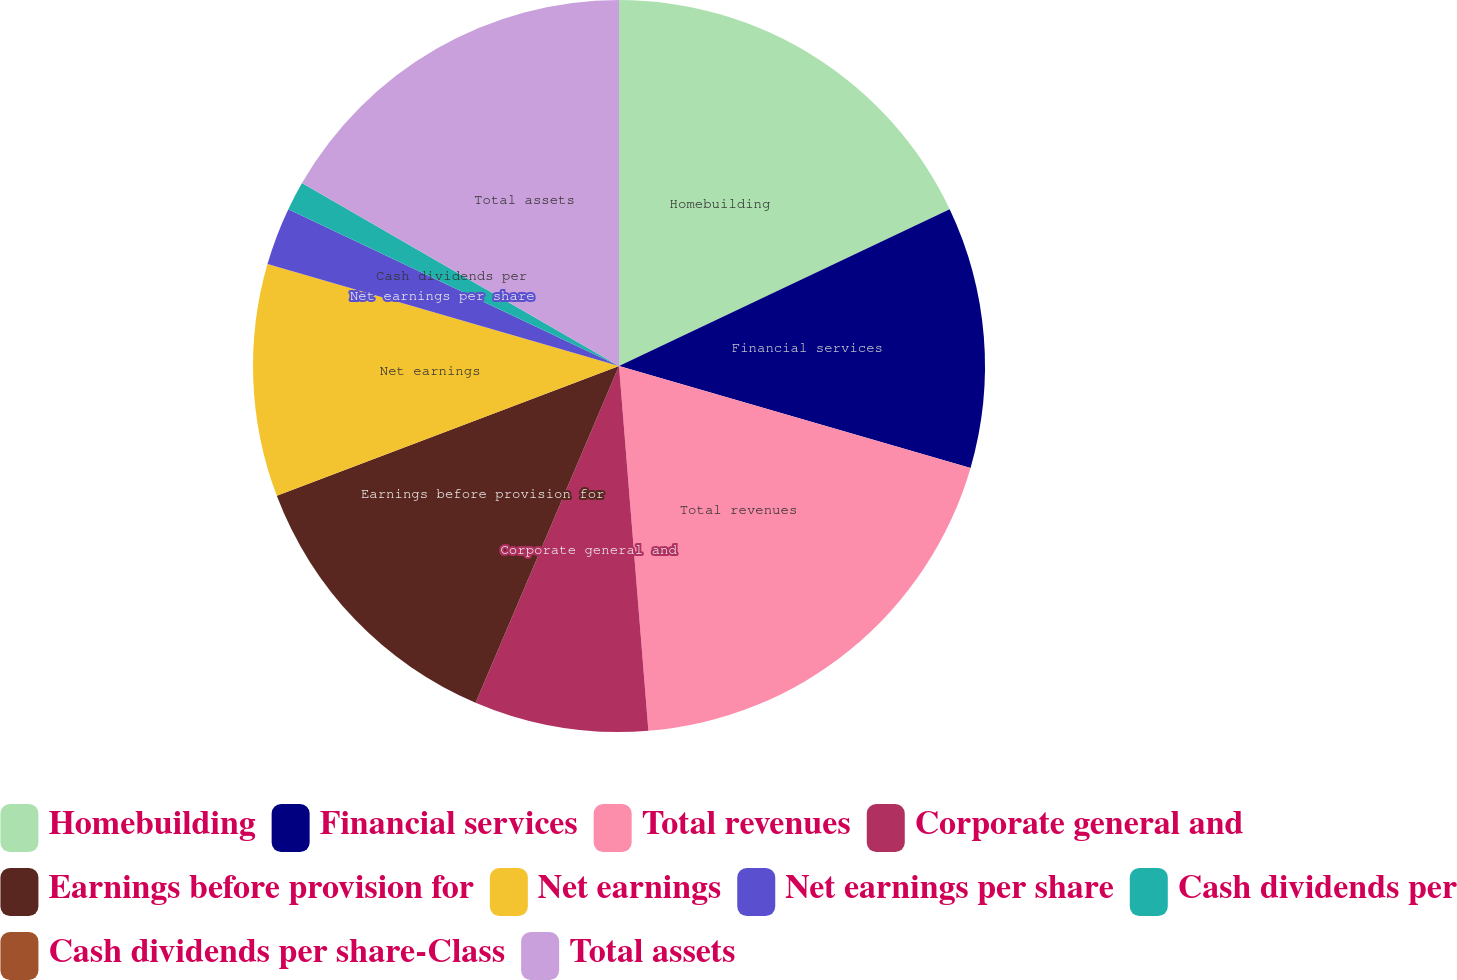Convert chart to OTSL. <chart><loc_0><loc_0><loc_500><loc_500><pie_chart><fcel>Homebuilding<fcel>Financial services<fcel>Total revenues<fcel>Corporate general and<fcel>Earnings before provision for<fcel>Net earnings<fcel>Net earnings per share<fcel>Cash dividends per<fcel>Cash dividends per share-Class<fcel>Total assets<nl><fcel>17.95%<fcel>11.54%<fcel>19.23%<fcel>7.69%<fcel>12.82%<fcel>10.26%<fcel>2.56%<fcel>1.28%<fcel>0.0%<fcel>16.67%<nl></chart> 